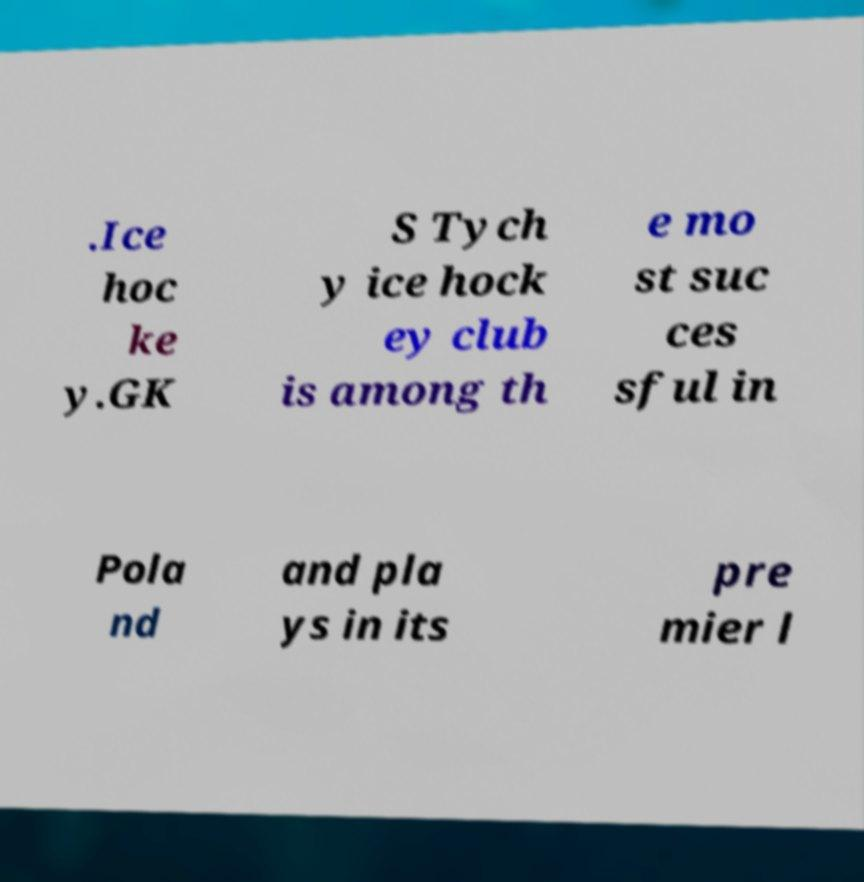What messages or text are displayed in this image? I need them in a readable, typed format. .Ice hoc ke y.GK S Tych y ice hock ey club is among th e mo st suc ces sful in Pola nd and pla ys in its pre mier l 